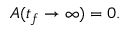<formula> <loc_0><loc_0><loc_500><loc_500>A ( t _ { f } \to \infty ) = 0 .</formula> 